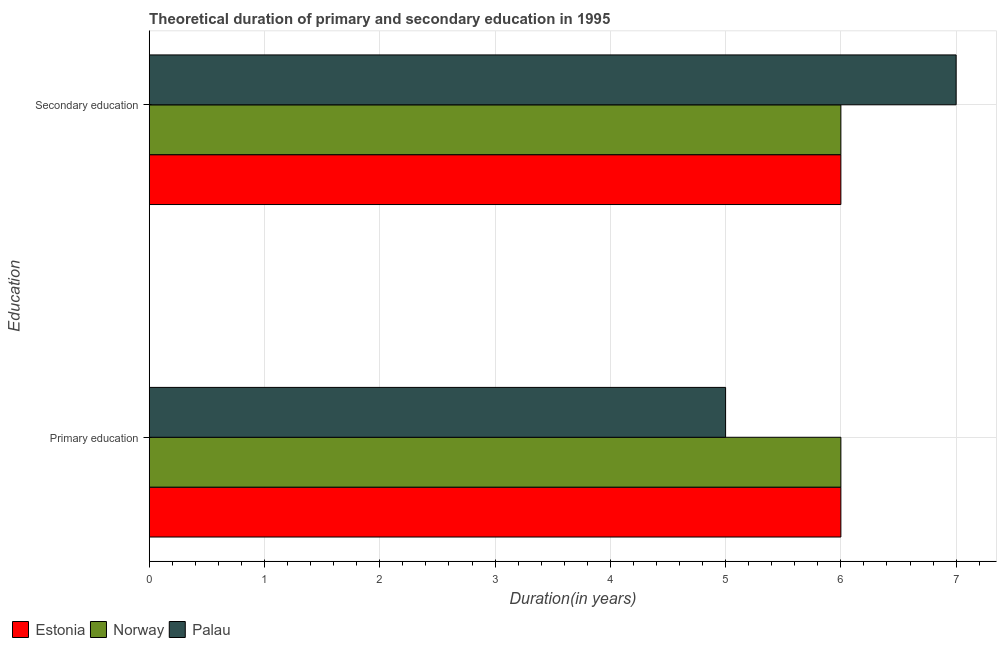How many different coloured bars are there?
Provide a succinct answer. 3. How many bars are there on the 2nd tick from the top?
Provide a short and direct response. 3. How many bars are there on the 1st tick from the bottom?
Provide a succinct answer. 3. What is the label of the 2nd group of bars from the top?
Provide a short and direct response. Primary education. What is the duration of secondary education in Palau?
Your answer should be very brief. 7. Across all countries, what is the maximum duration of primary education?
Give a very brief answer. 6. Across all countries, what is the minimum duration of primary education?
Provide a short and direct response. 5. In which country was the duration of primary education maximum?
Make the answer very short. Estonia. In which country was the duration of primary education minimum?
Offer a very short reply. Palau. What is the total duration of primary education in the graph?
Make the answer very short. 17. What is the difference between the duration of primary education in Estonia and that in Palau?
Offer a very short reply. 1. What is the difference between the duration of secondary education in Norway and the duration of primary education in Palau?
Make the answer very short. 1. What is the average duration of primary education per country?
Give a very brief answer. 5.67. What is the difference between the duration of primary education and duration of secondary education in Norway?
Offer a very short reply. 0. In how many countries, is the duration of primary education greater than 1.6 years?
Your answer should be compact. 3. What is the ratio of the duration of secondary education in Palau to that in Estonia?
Your answer should be compact. 1.17. What does the 1st bar from the top in Secondary education represents?
Your answer should be very brief. Palau. What does the 2nd bar from the bottom in Primary education represents?
Your answer should be compact. Norway. How many bars are there?
Offer a very short reply. 6. Are all the bars in the graph horizontal?
Keep it short and to the point. Yes. How many countries are there in the graph?
Ensure brevity in your answer.  3. What is the difference between two consecutive major ticks on the X-axis?
Your answer should be very brief. 1. Does the graph contain any zero values?
Keep it short and to the point. No. Does the graph contain grids?
Make the answer very short. Yes. Where does the legend appear in the graph?
Offer a terse response. Bottom left. How many legend labels are there?
Provide a succinct answer. 3. How are the legend labels stacked?
Your answer should be compact. Horizontal. What is the title of the graph?
Your response must be concise. Theoretical duration of primary and secondary education in 1995. Does "Monaco" appear as one of the legend labels in the graph?
Ensure brevity in your answer.  No. What is the label or title of the X-axis?
Offer a terse response. Duration(in years). What is the label or title of the Y-axis?
Give a very brief answer. Education. What is the Duration(in years) in Estonia in Primary education?
Offer a terse response. 6. What is the Duration(in years) in Palau in Primary education?
Provide a short and direct response. 5. What is the Duration(in years) in Estonia in Secondary education?
Offer a very short reply. 6. What is the Duration(in years) in Norway in Secondary education?
Provide a short and direct response. 6. What is the Duration(in years) of Palau in Secondary education?
Your response must be concise. 7. Across all Education, what is the maximum Duration(in years) in Estonia?
Provide a short and direct response. 6. Across all Education, what is the maximum Duration(in years) of Norway?
Offer a very short reply. 6. Across all Education, what is the minimum Duration(in years) in Norway?
Offer a terse response. 6. What is the total Duration(in years) of Estonia in the graph?
Your answer should be very brief. 12. What is the total Duration(in years) in Norway in the graph?
Your answer should be very brief. 12. What is the total Duration(in years) in Palau in the graph?
Keep it short and to the point. 12. What is the difference between the Duration(in years) of Palau in Primary education and that in Secondary education?
Provide a succinct answer. -2. What is the difference between the Duration(in years) of Estonia in Primary education and the Duration(in years) of Palau in Secondary education?
Provide a short and direct response. -1. What is the average Duration(in years) of Estonia per Education?
Offer a very short reply. 6. What is the average Duration(in years) of Norway per Education?
Ensure brevity in your answer.  6. What is the difference between the Duration(in years) of Estonia and Duration(in years) of Norway in Primary education?
Keep it short and to the point. 0. What is the difference between the Duration(in years) of Estonia and Duration(in years) of Palau in Primary education?
Provide a succinct answer. 1. What is the difference between the Duration(in years) of Estonia and Duration(in years) of Palau in Secondary education?
Your answer should be very brief. -1. What is the difference between the Duration(in years) in Norway and Duration(in years) in Palau in Secondary education?
Your answer should be very brief. -1. What is the ratio of the Duration(in years) in Estonia in Primary education to that in Secondary education?
Provide a succinct answer. 1. What is the ratio of the Duration(in years) of Palau in Primary education to that in Secondary education?
Ensure brevity in your answer.  0.71. What is the difference between the highest and the second highest Duration(in years) in Estonia?
Provide a succinct answer. 0. What is the difference between the highest and the second highest Duration(in years) of Norway?
Offer a very short reply. 0. What is the difference between the highest and the lowest Duration(in years) in Norway?
Offer a terse response. 0. What is the difference between the highest and the lowest Duration(in years) in Palau?
Your answer should be very brief. 2. 